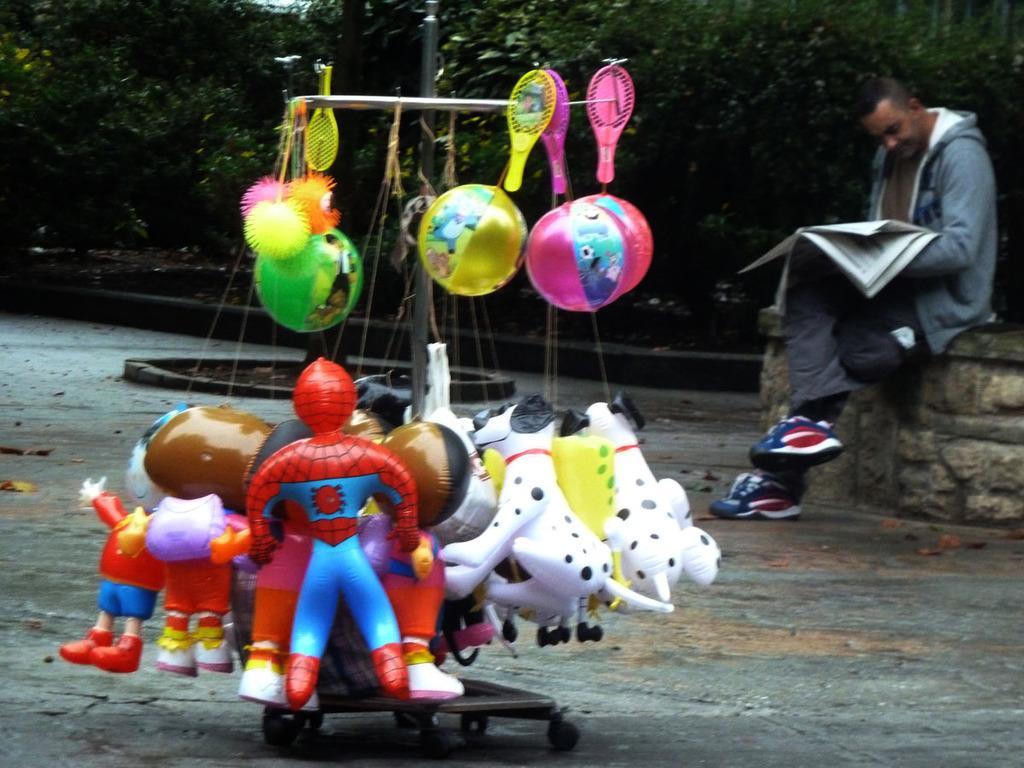Describe this image in one or two sentences. In this image we can see an object with the bats, balls and also the playing toys. We can also see a person holding the papers and sitting on the wall. We can see the path and also the trees. 